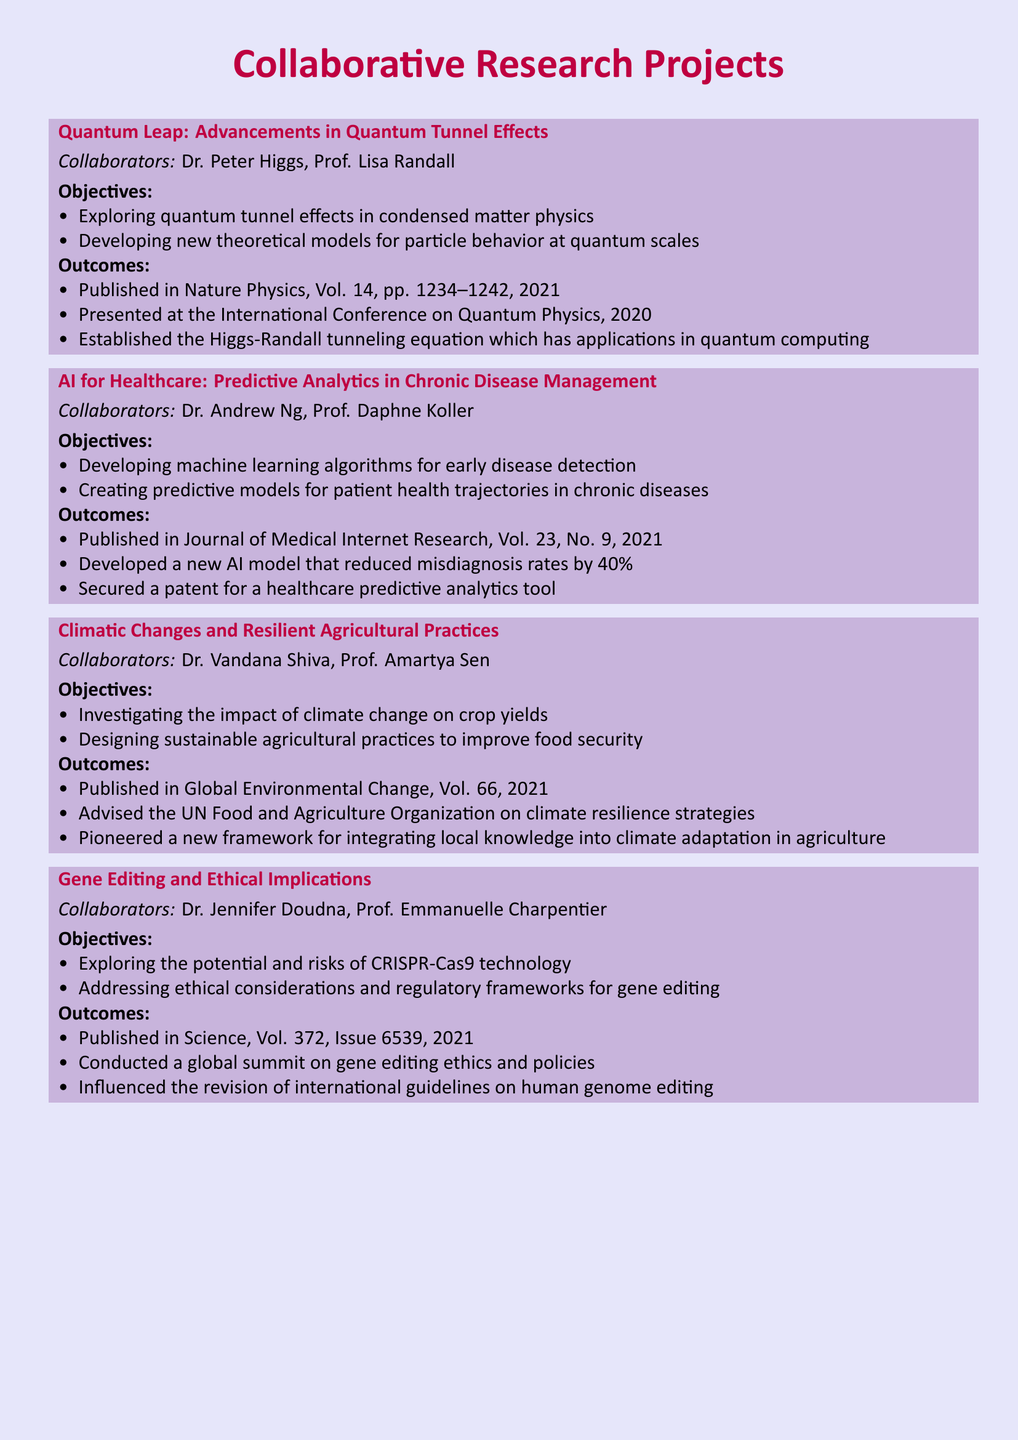What is the first project listed? The first project is titled "Quantum Leap: Advancements in Quantum Tunnel Effects."
Answer: Quantum Leap: Advancements in Quantum Tunnel Effects Who collaborated with Dr. Andrew Ng on the AI for Healthcare project? The collaborator with Dr. Andrew Ng is Prof. Daphne Koller.
Answer: Prof. Daphne Koller What year was the project on Gene Editing and Ethical Implications published? The project was published in the year 2021.
Answer: 2021 How much did the new AI model reduce misdiagnosis rates by? The AI model reduced misdiagnosis rates by 40%.
Answer: 40% Which journal published the outcomes of the project on Climatic Changes and Resilient Agricultural Practices? The outcomes were published in Global Environmental Change.
Answer: Global Environmental Change What is one of the objectives of the Quantum Leap project? One of the objectives is to explore quantum tunnel effects in condensed matter physics.
Answer: Exploring quantum tunnel effects in condensed matter physics How many significant outcomes are listed for the project on Gene Editing and Ethical Implications? There are three significant outcomes listed for this project.
Answer: Three What theoretical model was established in the Quantum Leap project? The Higgs-Randall tunneling equation was established.
Answer: Higgs-Randall tunneling equation 